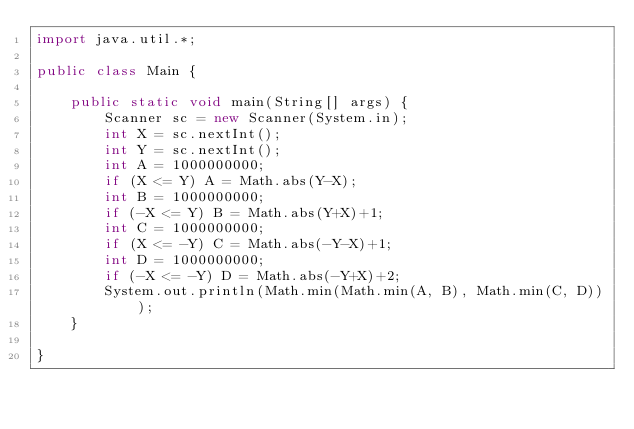Convert code to text. <code><loc_0><loc_0><loc_500><loc_500><_Java_>import java.util.*;

public class Main {
    
    public static void main(String[] args) {
        Scanner sc = new Scanner(System.in);
        int X = sc.nextInt();
        int Y = sc.nextInt();
        int A = 1000000000;
        if (X <= Y) A = Math.abs(Y-X);
        int B = 1000000000;
        if (-X <= Y) B = Math.abs(Y+X)+1;
        int C = 1000000000;
        if (X <= -Y) C = Math.abs(-Y-X)+1;
        int D = 1000000000;
        if (-X <= -Y) D = Math.abs(-Y+X)+2;
        System.out.println(Math.min(Math.min(A, B), Math.min(C, D))); 
    }
    
}</code> 